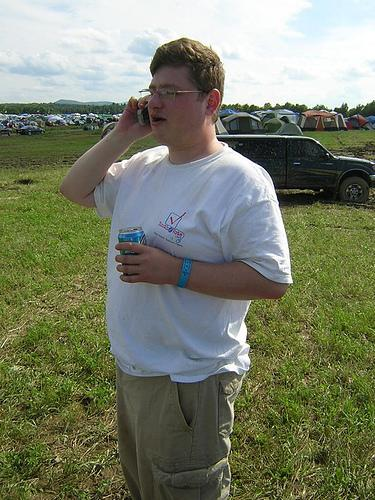What is his hairstyle? Please explain your reasoning. long. Haircut lengths are subjective however in today many consider the shaven head as being short.  the man in the photo has reasonable amount of hair and would thus be considered long. 